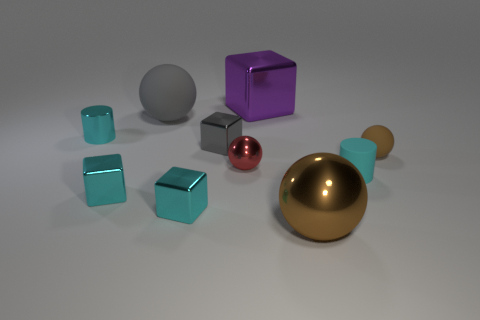How many cyan blocks must be subtracted to get 1 cyan blocks? 1 Subtract all large blocks. How many blocks are left? 3 Subtract all purple blocks. How many blocks are left? 3 Subtract all cylinders. How many objects are left? 8 Subtract 4 blocks. How many blocks are left? 0 Subtract all red cylinders. Subtract all yellow spheres. How many cylinders are left? 2 Subtract all brown balls. How many cyan blocks are left? 2 Subtract all yellow rubber things. Subtract all tiny brown balls. How many objects are left? 9 Add 6 small brown rubber objects. How many small brown rubber objects are left? 7 Add 4 small brown metal cylinders. How many small brown metal cylinders exist? 4 